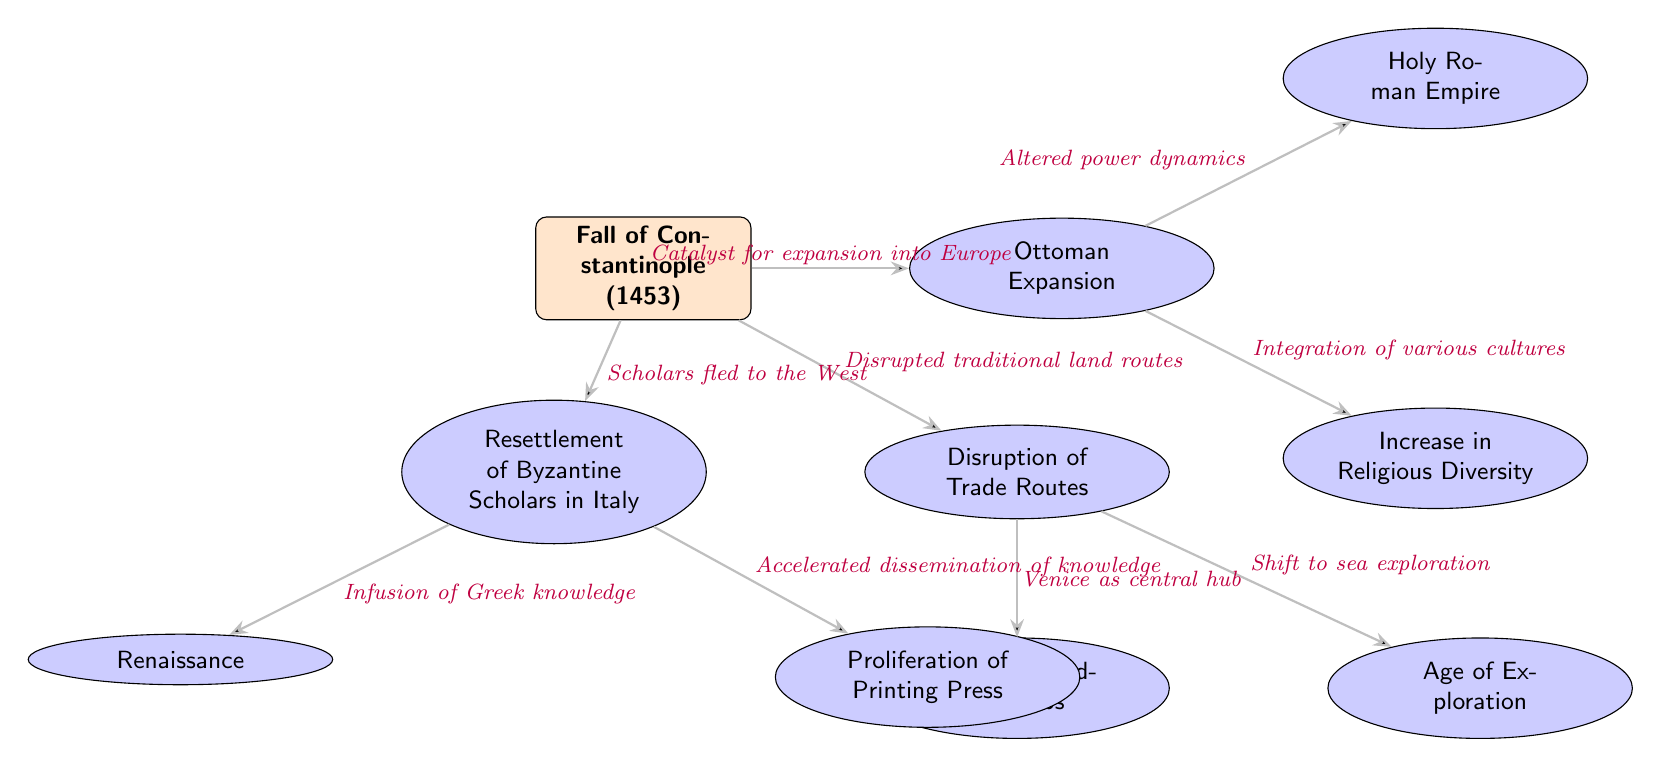What event is represented at the center of the diagram? The diagram's central node is labeled as "Fall of Constantinople (1453)", indicating it is the main event being examined.
Answer: Fall of Constantinople (1453) How many effects are directly linked to the Fall of Constantinople? The diagram shows five effects (nodes) connected to the central event, showing the various changes spurred by the Fall of Constantinople.
Answer: Five What impact did the Fall of Constantinople have on the Holy Roman Empire? The arrows indicate that the Fall of Constantinople altered the power dynamics, connecting it directly to the Holy Roman Empire in the diagram.
Answer: Altered power dynamics Which effect is associated with the Venetian Trading Hubs? The diagram illustrates that the "Venetian Trading Hubs" is linked to the "Disruption of Trade Routes," indicating the impact caused by the Fall of Constantinople.
Answer: Disruption of Trade Routes What cultural movement was influenced by the resettlement of Byzantine scholars in Italy? The connection in the diagram shows that the "Resettlement of Byzantine Scholars in Italy" leads to the "Renaissance," showcasing a significant cultural shift.
Answer: Renaissance What does the arrow labeled "Catalyst for expansion into Europe" connect to? This arrow connects the "Fall of Constantinople" node to the "Ottoman Expansion," indicating how the event prompted the Ottomans' growth into Europe.
Answer: Ottoman Expansion What was one primary consequence of disrupted traditional land routes? The diagram indicates that the "Disruption of Trade Routes" led to a "Shift to sea exploration," which exemplifies significant changes in trade practices afterward.
Answer: Shift to sea exploration Which two effects represent cultural advancements stemming from the Fall of Constantinople? The nodes labeled "Proliferation of Printing Press" and "Renaissance" directly illustrate cultural advancements that followed the event, linked through the resettlement of scholars and the infusion of knowledge.
Answer: Proliferation of Printing Press and Renaissance How did the Fall of Constantinople influence religious diversity? The link from "Ottoman Expansion" to "Increase in Religious Diversity" suggests that the event contributed to a greater mix of religions due to the Ottomans' rise.
Answer: Increase in Religious Diversity 